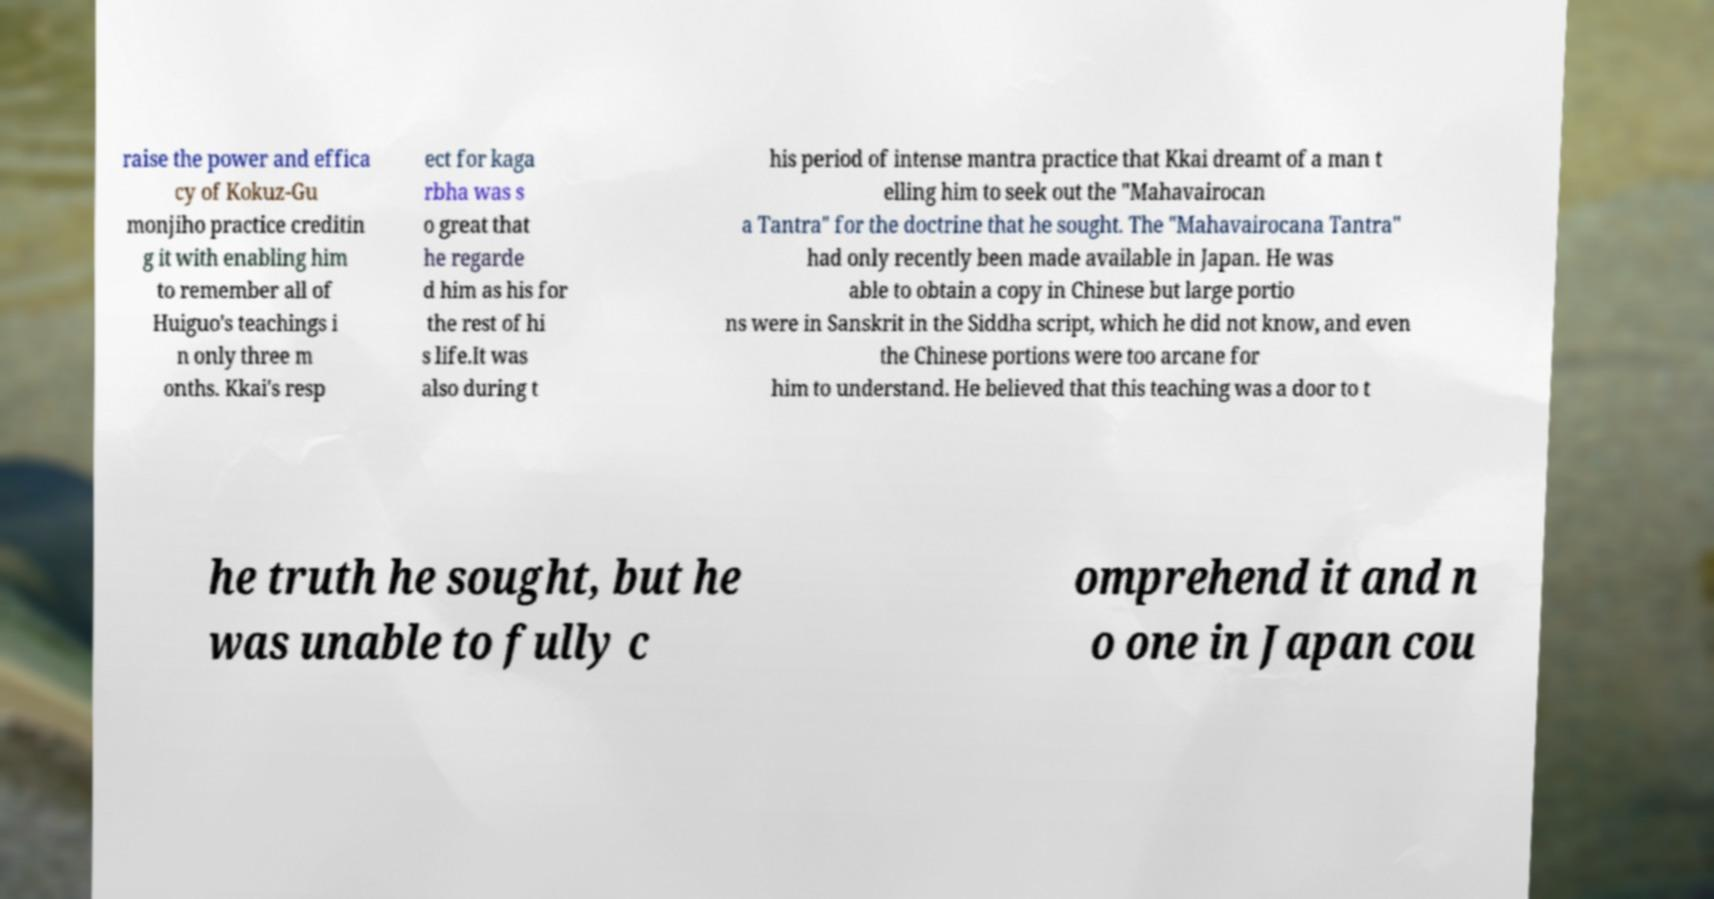Can you accurately transcribe the text from the provided image for me? raise the power and effica cy of Kokuz-Gu monjiho practice creditin g it with enabling him to remember all of Huiguo's teachings i n only three m onths. Kkai's resp ect for kaga rbha was s o great that he regarde d him as his for the rest of hi s life.It was also during t his period of intense mantra practice that Kkai dreamt of a man t elling him to seek out the "Mahavairocan a Tantra" for the doctrine that he sought. The "Mahavairocana Tantra" had only recently been made available in Japan. He was able to obtain a copy in Chinese but large portio ns were in Sanskrit in the Siddha script, which he did not know, and even the Chinese portions were too arcane for him to understand. He believed that this teaching was a door to t he truth he sought, but he was unable to fully c omprehend it and n o one in Japan cou 